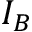Convert formula to latex. <formula><loc_0><loc_0><loc_500><loc_500>I _ { B }</formula> 